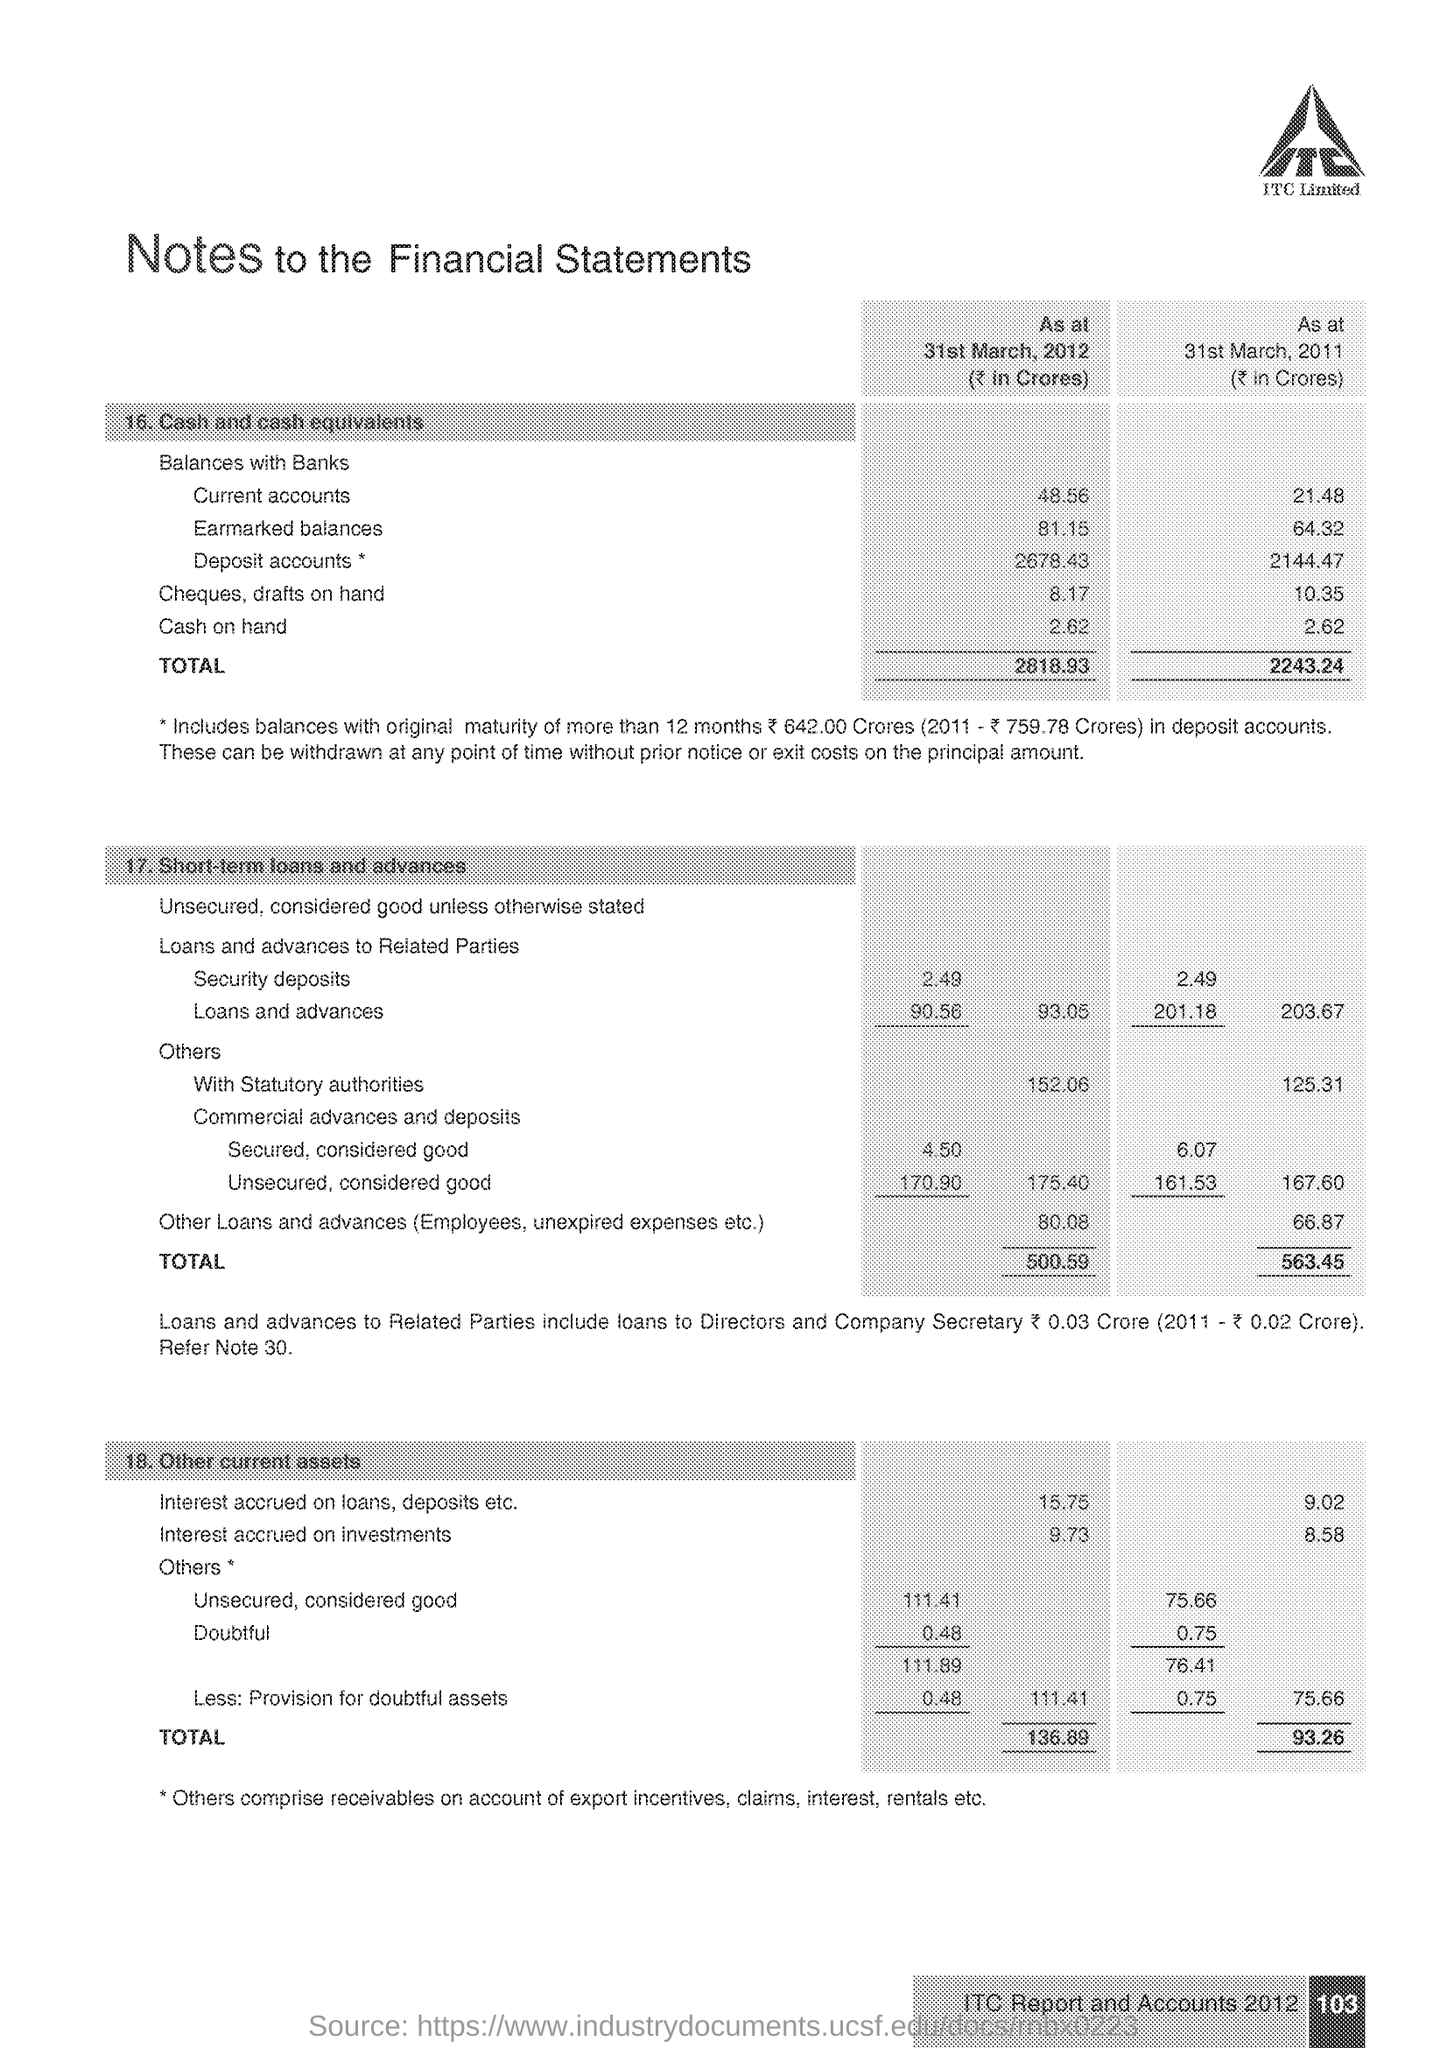What is the Company Name ?
Keep it short and to the point. ITC Limited. How much Cash on hand in 2012 ?
Your response must be concise. 2.62. What is the Title of the document ?
Your answer should be very brief. Notes to the Financial Statements. 